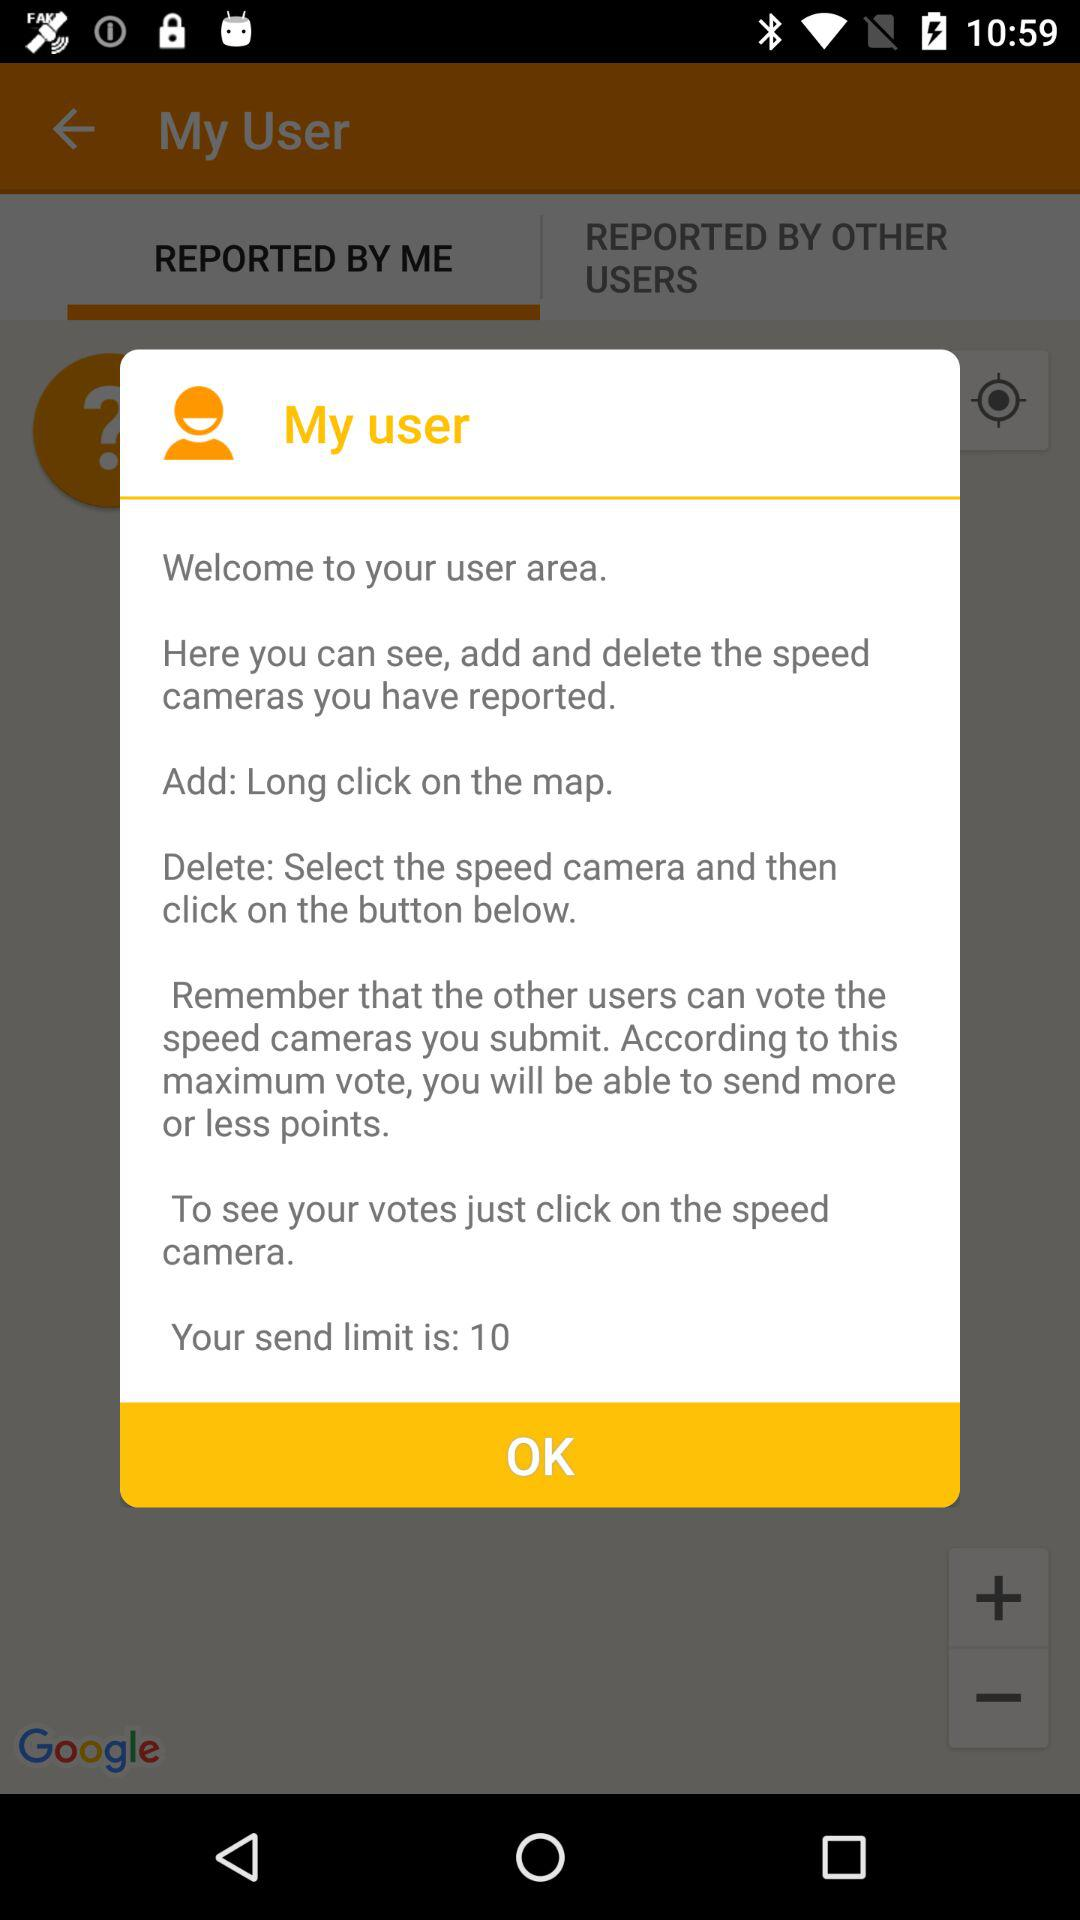How can we see our votes? You can see your votes by clicking on the speed camera. 